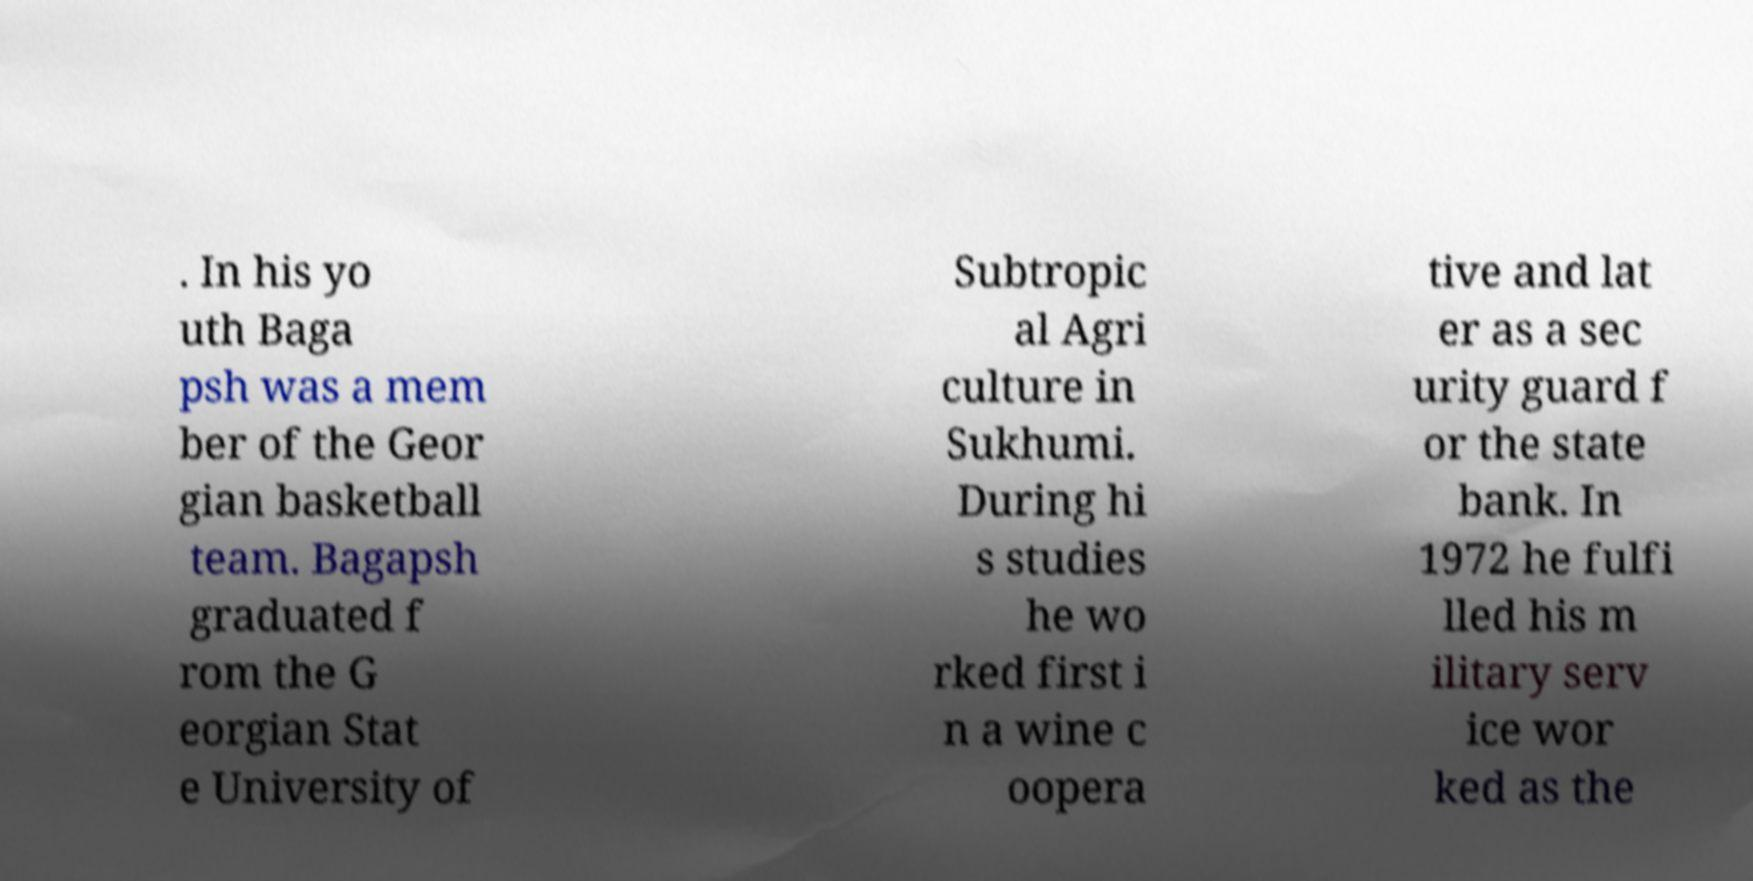Could you assist in decoding the text presented in this image and type it out clearly? . In his yo uth Baga psh was a mem ber of the Geor gian basketball team. Bagapsh graduated f rom the G eorgian Stat e University of Subtropic al Agri culture in Sukhumi. During hi s studies he wo rked first i n a wine c oopera tive and lat er as a sec urity guard f or the state bank. In 1972 he fulfi lled his m ilitary serv ice wor ked as the 